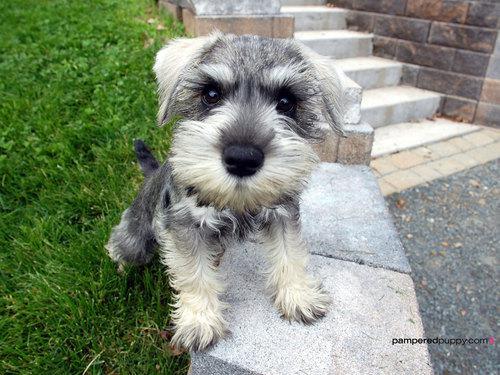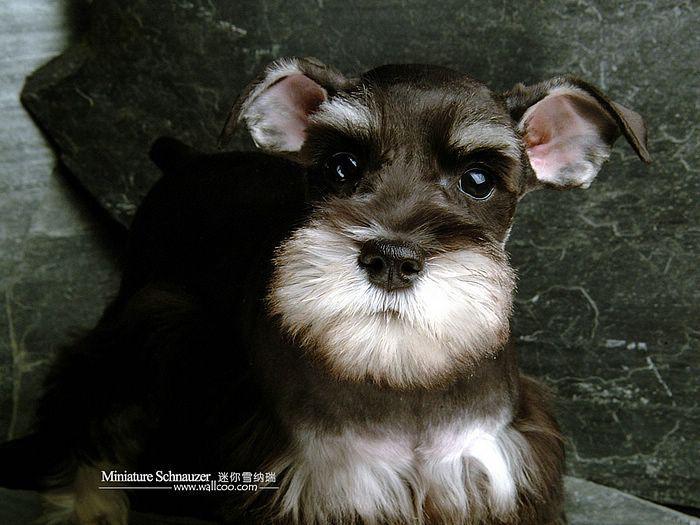The first image is the image on the left, the second image is the image on the right. For the images shown, is this caption "Left image features a schnauzer dog sitting inside a car on a seat." true? Answer yes or no. No. 